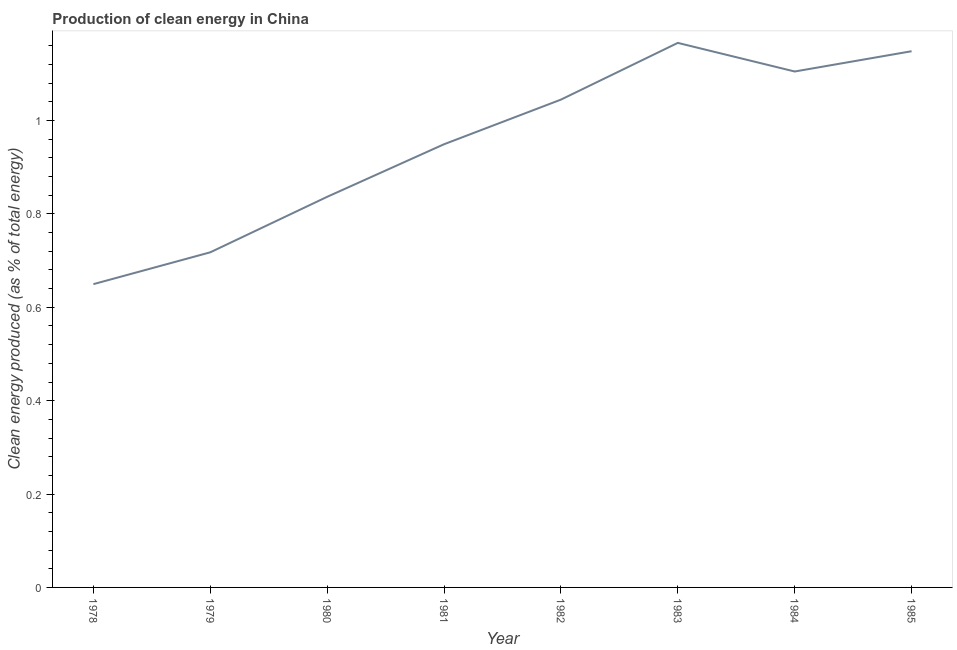What is the production of clean energy in 1984?
Your answer should be compact. 1.11. Across all years, what is the maximum production of clean energy?
Your response must be concise. 1.17. Across all years, what is the minimum production of clean energy?
Make the answer very short. 0.65. In which year was the production of clean energy maximum?
Offer a very short reply. 1983. In which year was the production of clean energy minimum?
Your response must be concise. 1978. What is the sum of the production of clean energy?
Make the answer very short. 7.62. What is the difference between the production of clean energy in 1980 and 1985?
Offer a terse response. -0.31. What is the average production of clean energy per year?
Provide a short and direct response. 0.95. What is the median production of clean energy?
Make the answer very short. 1. Do a majority of the years between 1985 and 1978 (inclusive) have production of clean energy greater than 0.8 %?
Offer a very short reply. Yes. What is the ratio of the production of clean energy in 1982 to that in 1983?
Provide a short and direct response. 0.9. Is the production of clean energy in 1983 less than that in 1984?
Ensure brevity in your answer.  No. What is the difference between the highest and the second highest production of clean energy?
Give a very brief answer. 0.02. What is the difference between the highest and the lowest production of clean energy?
Offer a terse response. 0.52. In how many years, is the production of clean energy greater than the average production of clean energy taken over all years?
Provide a short and direct response. 4. Does the production of clean energy monotonically increase over the years?
Your answer should be compact. No. How many lines are there?
Your answer should be very brief. 1. Does the graph contain grids?
Give a very brief answer. No. What is the title of the graph?
Your response must be concise. Production of clean energy in China. What is the label or title of the Y-axis?
Your answer should be very brief. Clean energy produced (as % of total energy). What is the Clean energy produced (as % of total energy) of 1978?
Your response must be concise. 0.65. What is the Clean energy produced (as % of total energy) in 1979?
Offer a terse response. 0.72. What is the Clean energy produced (as % of total energy) in 1980?
Your response must be concise. 0.84. What is the Clean energy produced (as % of total energy) in 1981?
Offer a very short reply. 0.95. What is the Clean energy produced (as % of total energy) of 1982?
Provide a succinct answer. 1.04. What is the Clean energy produced (as % of total energy) in 1983?
Offer a terse response. 1.17. What is the Clean energy produced (as % of total energy) in 1984?
Your response must be concise. 1.11. What is the Clean energy produced (as % of total energy) of 1985?
Offer a terse response. 1.15. What is the difference between the Clean energy produced (as % of total energy) in 1978 and 1979?
Provide a succinct answer. -0.07. What is the difference between the Clean energy produced (as % of total energy) in 1978 and 1980?
Offer a terse response. -0.19. What is the difference between the Clean energy produced (as % of total energy) in 1978 and 1981?
Your answer should be compact. -0.3. What is the difference between the Clean energy produced (as % of total energy) in 1978 and 1982?
Provide a short and direct response. -0.4. What is the difference between the Clean energy produced (as % of total energy) in 1978 and 1983?
Ensure brevity in your answer.  -0.52. What is the difference between the Clean energy produced (as % of total energy) in 1978 and 1984?
Provide a short and direct response. -0.46. What is the difference between the Clean energy produced (as % of total energy) in 1978 and 1985?
Make the answer very short. -0.5. What is the difference between the Clean energy produced (as % of total energy) in 1979 and 1980?
Your answer should be very brief. -0.12. What is the difference between the Clean energy produced (as % of total energy) in 1979 and 1981?
Provide a succinct answer. -0.23. What is the difference between the Clean energy produced (as % of total energy) in 1979 and 1982?
Offer a terse response. -0.33. What is the difference between the Clean energy produced (as % of total energy) in 1979 and 1983?
Ensure brevity in your answer.  -0.45. What is the difference between the Clean energy produced (as % of total energy) in 1979 and 1984?
Give a very brief answer. -0.39. What is the difference between the Clean energy produced (as % of total energy) in 1979 and 1985?
Your answer should be compact. -0.43. What is the difference between the Clean energy produced (as % of total energy) in 1980 and 1981?
Offer a very short reply. -0.11. What is the difference between the Clean energy produced (as % of total energy) in 1980 and 1982?
Ensure brevity in your answer.  -0.21. What is the difference between the Clean energy produced (as % of total energy) in 1980 and 1983?
Your answer should be very brief. -0.33. What is the difference between the Clean energy produced (as % of total energy) in 1980 and 1984?
Offer a terse response. -0.27. What is the difference between the Clean energy produced (as % of total energy) in 1980 and 1985?
Your response must be concise. -0.31. What is the difference between the Clean energy produced (as % of total energy) in 1981 and 1982?
Make the answer very short. -0.1. What is the difference between the Clean energy produced (as % of total energy) in 1981 and 1983?
Your answer should be very brief. -0.22. What is the difference between the Clean energy produced (as % of total energy) in 1981 and 1984?
Offer a terse response. -0.16. What is the difference between the Clean energy produced (as % of total energy) in 1981 and 1985?
Your answer should be compact. -0.2. What is the difference between the Clean energy produced (as % of total energy) in 1982 and 1983?
Your response must be concise. -0.12. What is the difference between the Clean energy produced (as % of total energy) in 1982 and 1984?
Offer a very short reply. -0.06. What is the difference between the Clean energy produced (as % of total energy) in 1982 and 1985?
Keep it short and to the point. -0.1. What is the difference between the Clean energy produced (as % of total energy) in 1983 and 1984?
Offer a terse response. 0.06. What is the difference between the Clean energy produced (as % of total energy) in 1983 and 1985?
Your answer should be very brief. 0.02. What is the difference between the Clean energy produced (as % of total energy) in 1984 and 1985?
Offer a very short reply. -0.04. What is the ratio of the Clean energy produced (as % of total energy) in 1978 to that in 1979?
Your answer should be compact. 0.91. What is the ratio of the Clean energy produced (as % of total energy) in 1978 to that in 1980?
Provide a short and direct response. 0.78. What is the ratio of the Clean energy produced (as % of total energy) in 1978 to that in 1981?
Make the answer very short. 0.68. What is the ratio of the Clean energy produced (as % of total energy) in 1978 to that in 1982?
Provide a short and direct response. 0.62. What is the ratio of the Clean energy produced (as % of total energy) in 1978 to that in 1983?
Ensure brevity in your answer.  0.56. What is the ratio of the Clean energy produced (as % of total energy) in 1978 to that in 1984?
Your answer should be compact. 0.59. What is the ratio of the Clean energy produced (as % of total energy) in 1978 to that in 1985?
Make the answer very short. 0.57. What is the ratio of the Clean energy produced (as % of total energy) in 1979 to that in 1980?
Ensure brevity in your answer.  0.86. What is the ratio of the Clean energy produced (as % of total energy) in 1979 to that in 1981?
Offer a very short reply. 0.76. What is the ratio of the Clean energy produced (as % of total energy) in 1979 to that in 1982?
Give a very brief answer. 0.69. What is the ratio of the Clean energy produced (as % of total energy) in 1979 to that in 1983?
Your answer should be very brief. 0.61. What is the ratio of the Clean energy produced (as % of total energy) in 1979 to that in 1984?
Make the answer very short. 0.65. What is the ratio of the Clean energy produced (as % of total energy) in 1980 to that in 1981?
Offer a terse response. 0.88. What is the ratio of the Clean energy produced (as % of total energy) in 1980 to that in 1982?
Offer a terse response. 0.8. What is the ratio of the Clean energy produced (as % of total energy) in 1980 to that in 1983?
Your response must be concise. 0.72. What is the ratio of the Clean energy produced (as % of total energy) in 1980 to that in 1984?
Ensure brevity in your answer.  0.76. What is the ratio of the Clean energy produced (as % of total energy) in 1980 to that in 1985?
Give a very brief answer. 0.73. What is the ratio of the Clean energy produced (as % of total energy) in 1981 to that in 1982?
Give a very brief answer. 0.91. What is the ratio of the Clean energy produced (as % of total energy) in 1981 to that in 1983?
Offer a very short reply. 0.81. What is the ratio of the Clean energy produced (as % of total energy) in 1981 to that in 1984?
Make the answer very short. 0.86. What is the ratio of the Clean energy produced (as % of total energy) in 1981 to that in 1985?
Make the answer very short. 0.83. What is the ratio of the Clean energy produced (as % of total energy) in 1982 to that in 1983?
Your answer should be very brief. 0.9. What is the ratio of the Clean energy produced (as % of total energy) in 1982 to that in 1984?
Give a very brief answer. 0.94. What is the ratio of the Clean energy produced (as % of total energy) in 1982 to that in 1985?
Your answer should be very brief. 0.91. What is the ratio of the Clean energy produced (as % of total energy) in 1983 to that in 1984?
Your answer should be very brief. 1.05. What is the ratio of the Clean energy produced (as % of total energy) in 1983 to that in 1985?
Keep it short and to the point. 1.02. 